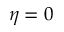<formula> <loc_0><loc_0><loc_500><loc_500>\eta = 0</formula> 